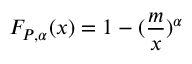Convert formula to latex. <formula><loc_0><loc_0><loc_500><loc_500>F _ { P , \alpha } ( x ) = 1 - ( \frac { m } { x } ) ^ { \alpha }</formula> 